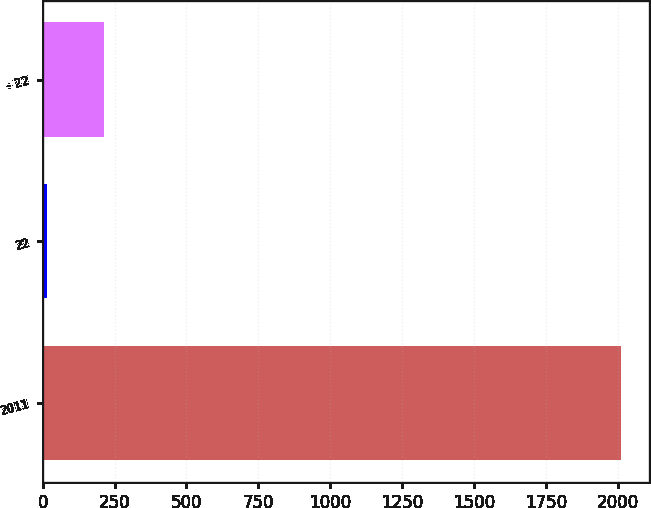Convert chart to OTSL. <chart><loc_0><loc_0><loc_500><loc_500><bar_chart><fcel>2011<fcel>22<fcel>- 22<nl><fcel>2010<fcel>15<fcel>214.5<nl></chart> 